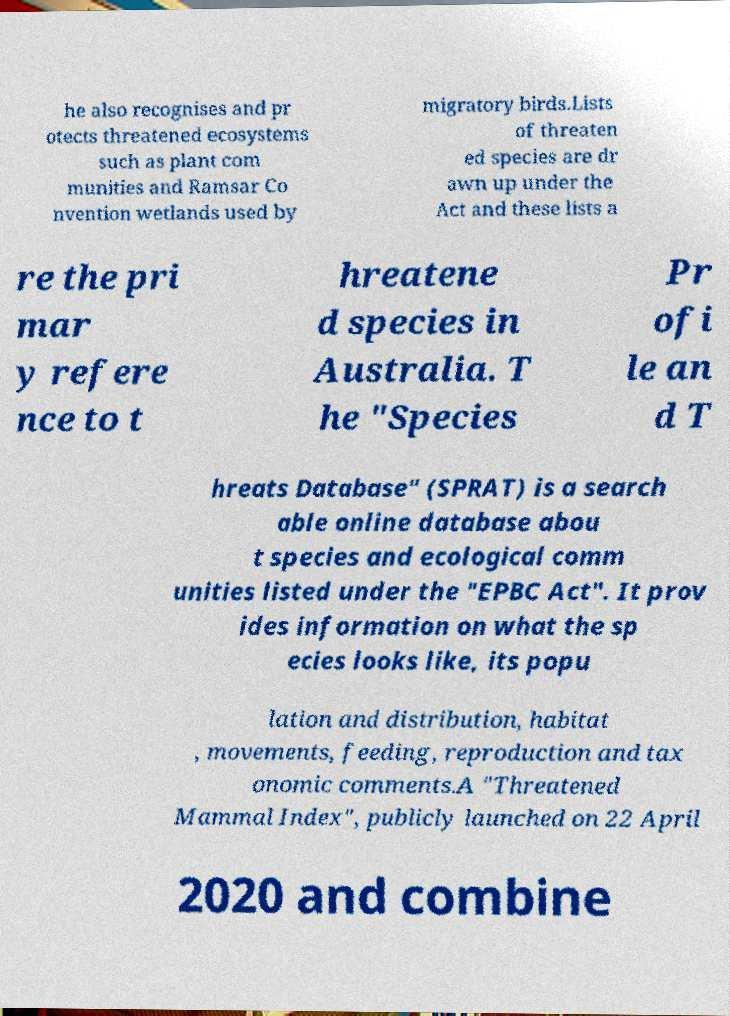Please identify and transcribe the text found in this image. he also recognises and pr otects threatened ecosystems such as plant com munities and Ramsar Co nvention wetlands used by migratory birds.Lists of threaten ed species are dr awn up under the Act and these lists a re the pri mar y refere nce to t hreatene d species in Australia. T he "Species Pr ofi le an d T hreats Database" (SPRAT) is a search able online database abou t species and ecological comm unities listed under the "EPBC Act". It prov ides information on what the sp ecies looks like, its popu lation and distribution, habitat , movements, feeding, reproduction and tax onomic comments.A "Threatened Mammal Index", publicly launched on 22 April 2020 and combine 